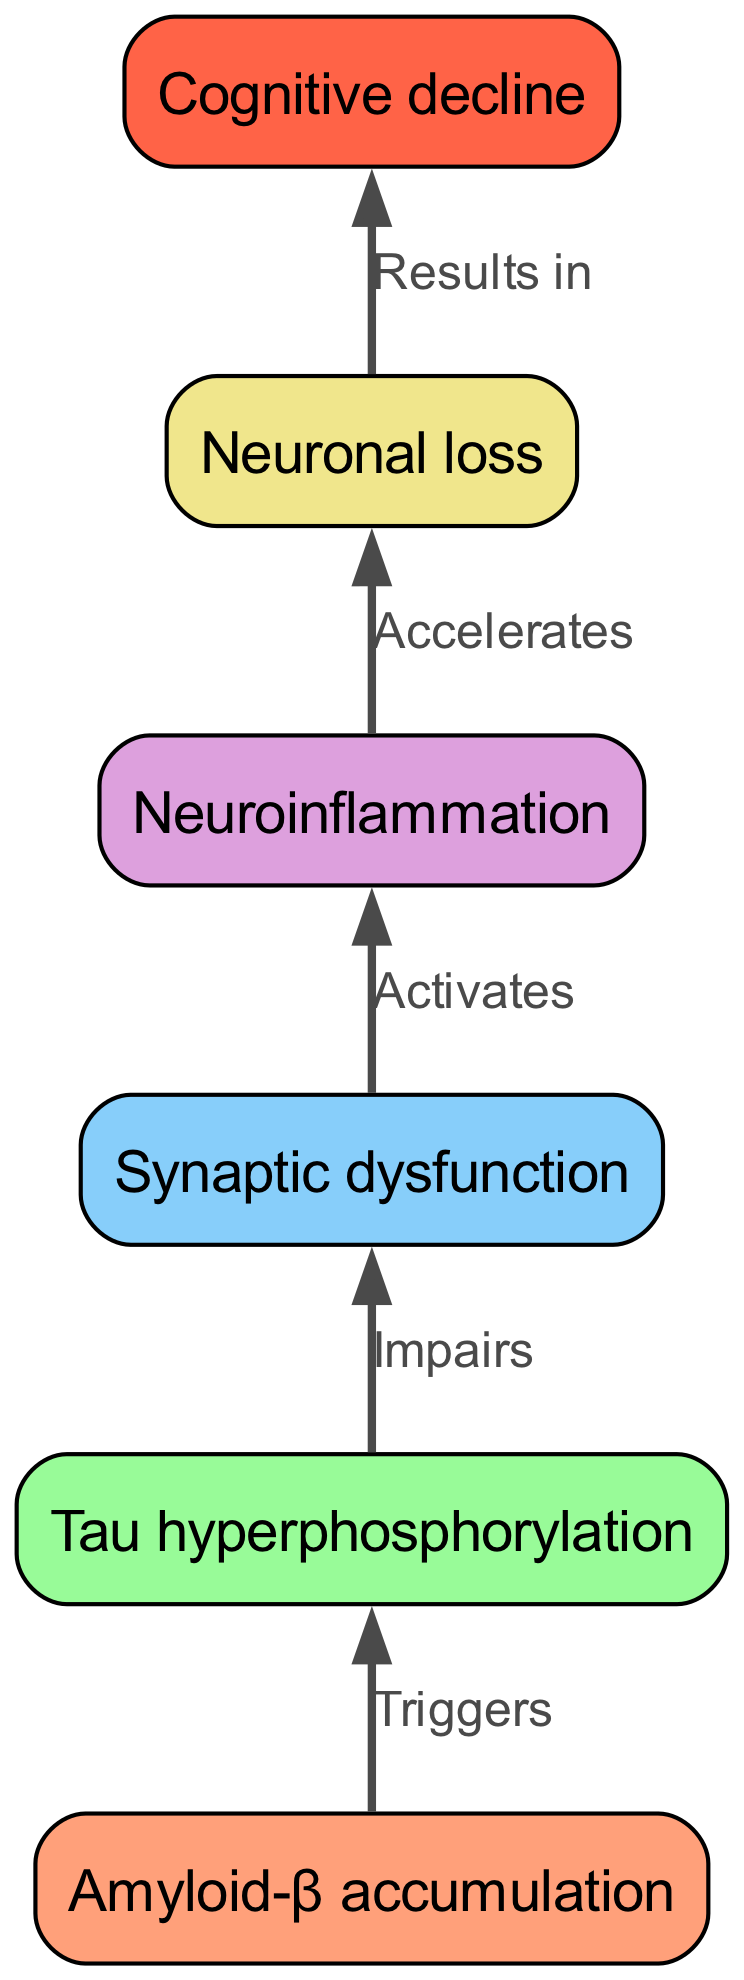What is the first stage of neurodegeneration depicted in the diagram? The diagram indicates that "Amyloid-β accumulation" is the initial stage, as it is positioned at the bottom of the flow chart, representing the starting point of the neurodegenerative process in Alzheimer's disease.
Answer: Amyloid-β accumulation How many nodes are present in the diagram? By reviewing the diagram, we can count the distinct stages represented, which are "Amyloid-β accumulation," "Tau hyperphosphorylation," "Synaptic dysfunction," "Neuroinflammation," "Neuronal loss," and "Cognitive decline," totaling six nodes.
Answer: 6 What does "Tau hyperphosphorylation" impair? The edge connecting "Tau hyperphosphorylation" to "Synaptic dysfunction" states that it "impairs" synaptic function, indicating the direct effect this stage has on the subsequent node.
Answer: Synaptic dysfunction Which node follows "Neuroinflammation"? In the flow of the diagram, "Neuroinflammation" is connected to "Neuronal loss," indicating that neuronal loss is the subsequent stage after neuroinflammation in the neurodegenerative process.
Answer: Neuronal loss What effect does "Synaptic dysfunction" have on "Neuroinflammation"? The connection between "Synaptic dysfunction" and "Neuroinflammation" shows that synaptic dysfunction "activates" the neuroinflammatory process, indicating a progression from synaptic issues to inflammation.
Answer: Activates What relationship is described between "Amyloid-β accumulation" and "Tau hyperphosphorylation"? The diagram indicates that "Amyloid-β accumulation" "triggers" "Tau hyperphosphorylation," establishing a cause-and-effect relationship where the accumulation of amyloid-β initiates the phosphorylation of tau proteins.
Answer: Triggers What is the final outcome of the neurodegeneration process shown in the diagram? The last node in the diagram, "Cognitive decline," is linked to "Neuronal loss" with the phrase "Results in," indicating that the overall outcome of the neurodegenerative stages culminates in cognitive decline.
Answer: Cognitive decline What role does "Neuroinflammation" play in the progression of neurodegeneration? The diagram indicates that "Neuroinflammation" "accelerates" "Neuronal loss," suggesting that inflammation not only contributes to but also speeds up the process of neuronal cell death as the disease progresses.
Answer: Accelerates How do the edges relate to the progression of Alzheimer's disease? The edges in the diagram illustrate directional relationships that represent causal or impactful connections between the nodes, guiding the viewer through the sequential stages of neurodegeneration in Alzheimer's disease.
Answer: Directional relationships 